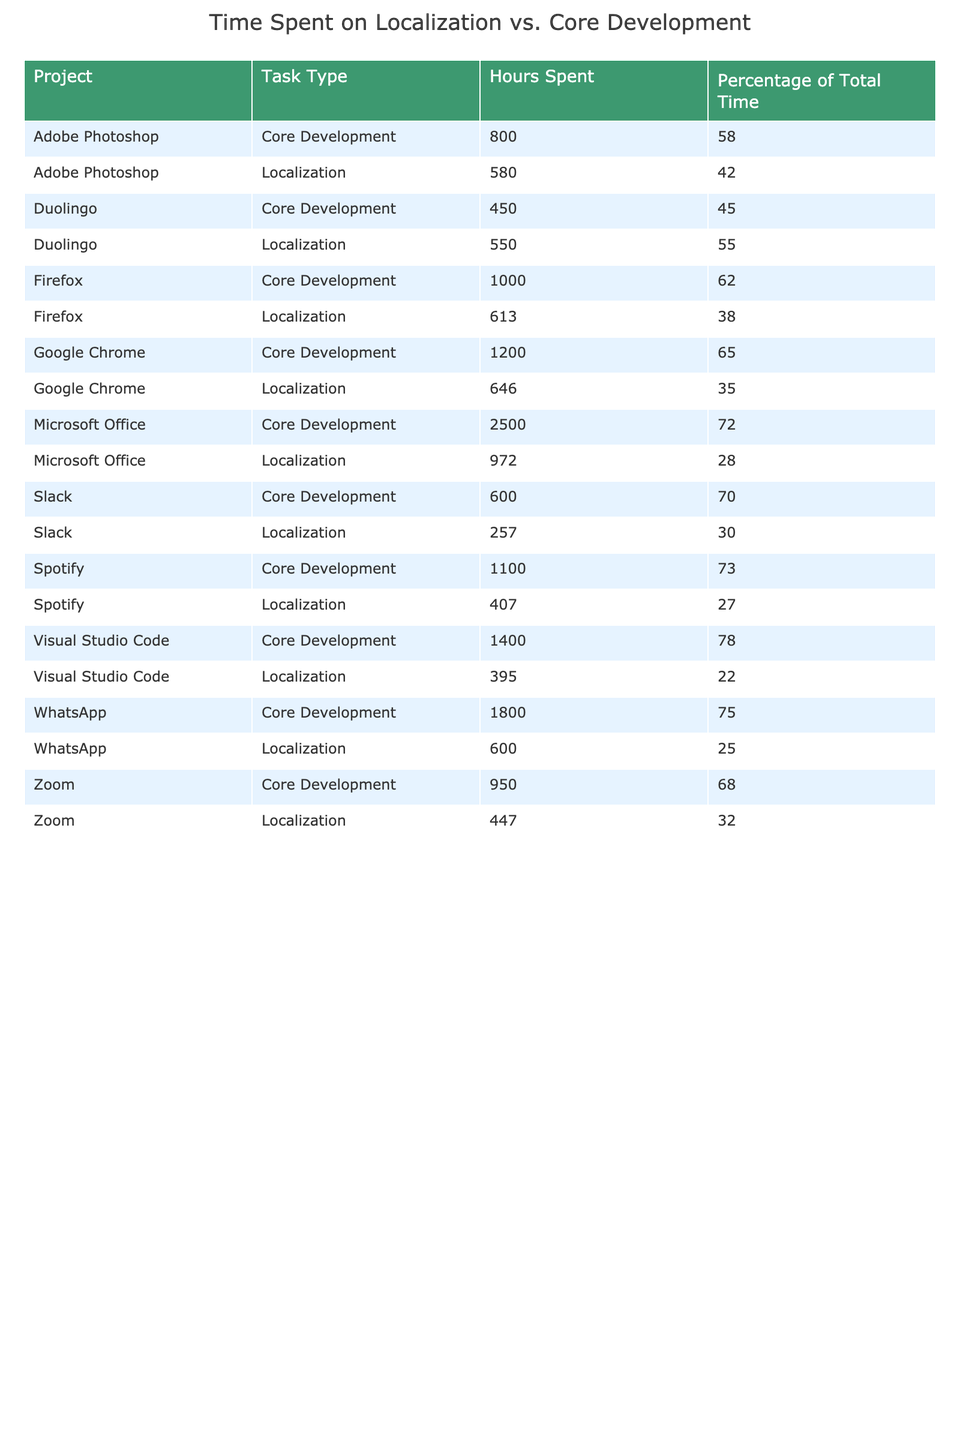What is the total time spent on localization tasks for Google Chrome? The table shows that Google Chrome spent 646 hours on localization tasks.
Answer: 646 hours Which project has the highest percentage of time spent on localization? By comparing the percentages in the table, Duolingo has the highest percentage of time spent on localization at 55%.
Answer: Duolingo What is the total time spent on core development and localization for Microsoft Office? For Microsoft Office, core development is 2500 hours and localization is 972 hours. The total is 2500 + 972 = 3472 hours.
Answer: 3472 hours Is the time spent on localization for Slack greater than that for Firefox? Slack's localization time is 257 hours, while Firefox's is 613 hours. Since 257 is less than 613, the statement is false.
Answer: No What is the average percentage of total time spent on localization across all projects? To find the average, sum all localization percentages (35 + 28 + 42 + 30 + 32 + 27 + 55 + 25 + 38 + 22) =  359. Then divide by the number of projects, which is 10. So, 359 / 10 = 35.9%.
Answer: 35.9% Which project has the highest total hours spent on core development? By looking at the table, Microsoft Office has the highest hours for core development at 2500 hours.
Answer: Microsoft Office What is the difference in hours spent on core development between WhatsApp and Zoom? WhatsApp spent 1800 hours on core development and Zoom spent 950 hours. The difference is 1800 - 950 = 850 hours.
Answer: 850 hours Are the total hours spent on localization tasks for Adobe Photoshop more than those for Spotify? Adobe Photoshop spent 580 hours on localization, and Spotify spent 407 hours. Since 580 is greater than 407, the answer is yes.
Answer: Yes Which project spent the least amount of time on core development, and what was that time? Scanning the table, Duolingo has the least at 450 hours for core development.
Answer: Duolingo, 450 hours What is the combined total time spent on localization for both Google Chrome and Adobe Photoshop? Google Chrome spent 646 hours and Adobe Photoshop spent 580 hours on localization. Adding them gives 646 + 580 = 1226 hours.
Answer: 1226 hours Which project has a higher percentage of localization hours: Slack or WhatsApp? Slack has 30% for localization and WhatsApp has 25%. Since 30% is greater than 25%, Slack has a higher percentage.
Answer: Slack 